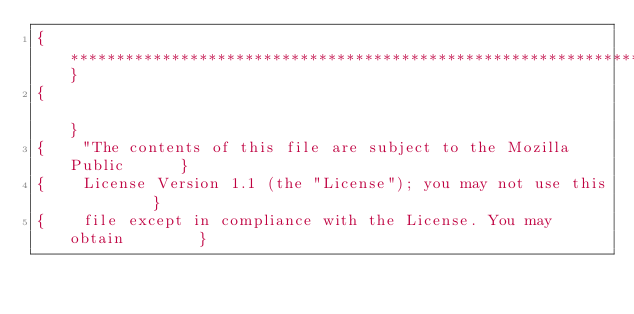<code> <loc_0><loc_0><loc_500><loc_500><_Pascal_>{**********************************************************************}
{                                                                      }
{    "The contents of this file are subject to the Mozilla Public      }
{    License Version 1.1 (the "License"); you may not use this         }
{    file except in compliance with the License. You may obtain        }</code> 